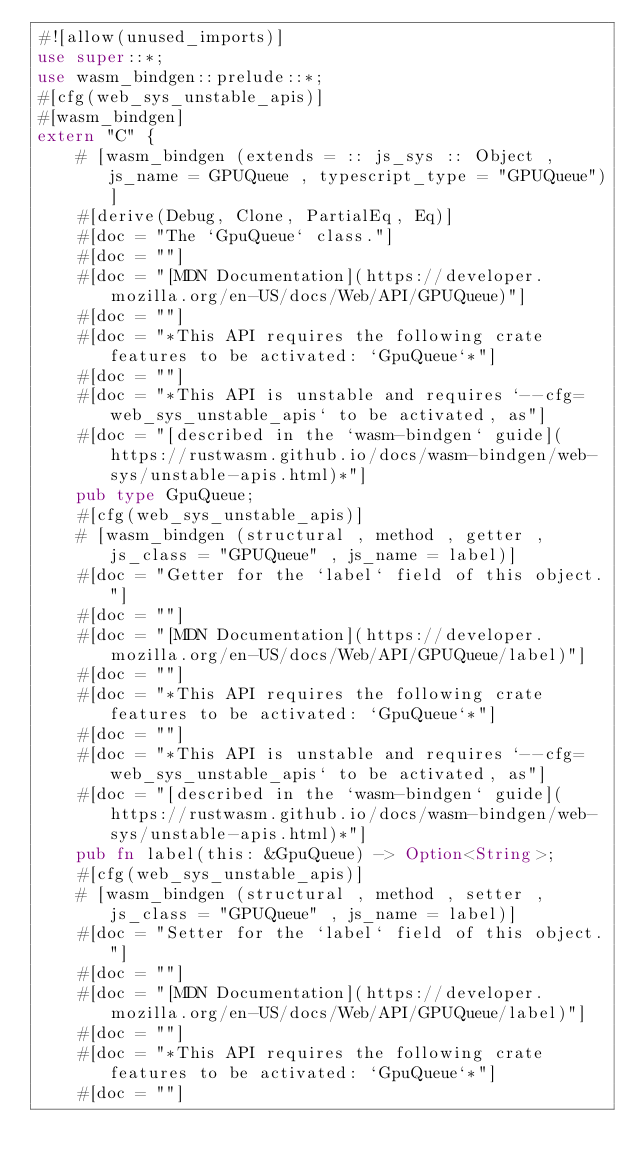<code> <loc_0><loc_0><loc_500><loc_500><_Rust_>#![allow(unused_imports)]
use super::*;
use wasm_bindgen::prelude::*;
#[cfg(web_sys_unstable_apis)]
#[wasm_bindgen]
extern "C" {
    # [wasm_bindgen (extends = :: js_sys :: Object , js_name = GPUQueue , typescript_type = "GPUQueue")]
    #[derive(Debug, Clone, PartialEq, Eq)]
    #[doc = "The `GpuQueue` class."]
    #[doc = ""]
    #[doc = "[MDN Documentation](https://developer.mozilla.org/en-US/docs/Web/API/GPUQueue)"]
    #[doc = ""]
    #[doc = "*This API requires the following crate features to be activated: `GpuQueue`*"]
    #[doc = ""]
    #[doc = "*This API is unstable and requires `--cfg=web_sys_unstable_apis` to be activated, as"]
    #[doc = "[described in the `wasm-bindgen` guide](https://rustwasm.github.io/docs/wasm-bindgen/web-sys/unstable-apis.html)*"]
    pub type GpuQueue;
    #[cfg(web_sys_unstable_apis)]
    # [wasm_bindgen (structural , method , getter , js_class = "GPUQueue" , js_name = label)]
    #[doc = "Getter for the `label` field of this object."]
    #[doc = ""]
    #[doc = "[MDN Documentation](https://developer.mozilla.org/en-US/docs/Web/API/GPUQueue/label)"]
    #[doc = ""]
    #[doc = "*This API requires the following crate features to be activated: `GpuQueue`*"]
    #[doc = ""]
    #[doc = "*This API is unstable and requires `--cfg=web_sys_unstable_apis` to be activated, as"]
    #[doc = "[described in the `wasm-bindgen` guide](https://rustwasm.github.io/docs/wasm-bindgen/web-sys/unstable-apis.html)*"]
    pub fn label(this: &GpuQueue) -> Option<String>;
    #[cfg(web_sys_unstable_apis)]
    # [wasm_bindgen (structural , method , setter , js_class = "GPUQueue" , js_name = label)]
    #[doc = "Setter for the `label` field of this object."]
    #[doc = ""]
    #[doc = "[MDN Documentation](https://developer.mozilla.org/en-US/docs/Web/API/GPUQueue/label)"]
    #[doc = ""]
    #[doc = "*This API requires the following crate features to be activated: `GpuQueue`*"]
    #[doc = ""]</code> 